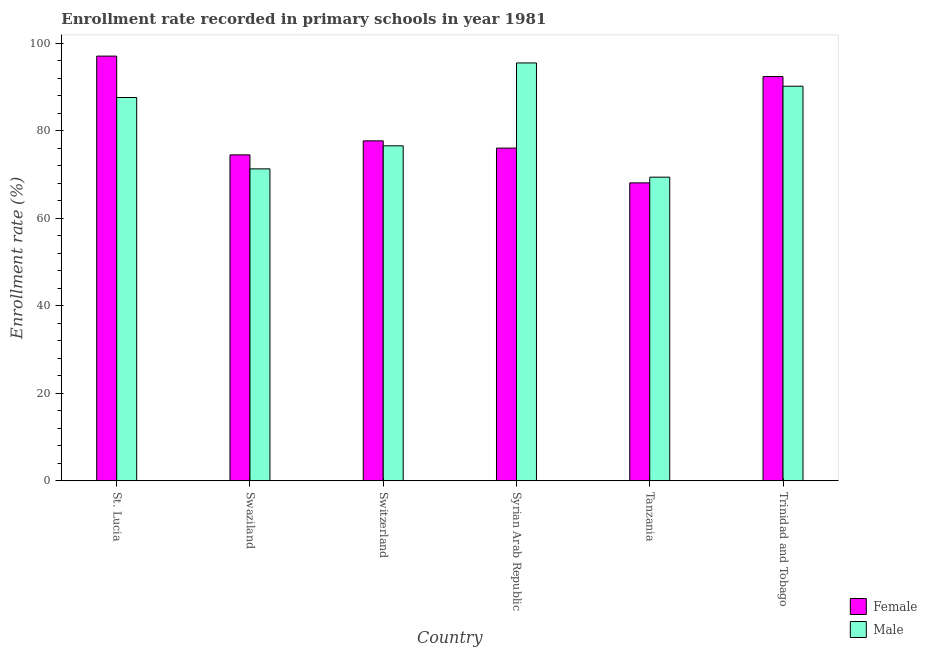How many bars are there on the 3rd tick from the left?
Your response must be concise. 2. What is the label of the 5th group of bars from the left?
Provide a short and direct response. Tanzania. In how many cases, is the number of bars for a given country not equal to the number of legend labels?
Offer a very short reply. 0. What is the enrollment rate of male students in Syrian Arab Republic?
Your answer should be very brief. 95.54. Across all countries, what is the maximum enrollment rate of male students?
Make the answer very short. 95.54. Across all countries, what is the minimum enrollment rate of female students?
Offer a terse response. 68.11. In which country was the enrollment rate of female students maximum?
Make the answer very short. St. Lucia. In which country was the enrollment rate of male students minimum?
Give a very brief answer. Tanzania. What is the total enrollment rate of male students in the graph?
Make the answer very short. 490.7. What is the difference between the enrollment rate of male students in St. Lucia and that in Trinidad and Tobago?
Provide a short and direct response. -2.58. What is the difference between the enrollment rate of female students in Syrian Arab Republic and the enrollment rate of male students in Switzerland?
Your answer should be compact. -0.52. What is the average enrollment rate of female students per country?
Keep it short and to the point. 80.99. What is the difference between the enrollment rate of male students and enrollment rate of female students in St. Lucia?
Your answer should be very brief. -9.46. What is the ratio of the enrollment rate of male students in Swaziland to that in Trinidad and Tobago?
Make the answer very short. 0.79. Is the difference between the enrollment rate of female students in St. Lucia and Syrian Arab Republic greater than the difference between the enrollment rate of male students in St. Lucia and Syrian Arab Republic?
Your response must be concise. Yes. What is the difference between the highest and the second highest enrollment rate of male students?
Give a very brief answer. 5.32. What is the difference between the highest and the lowest enrollment rate of male students?
Your answer should be compact. 26.12. In how many countries, is the enrollment rate of male students greater than the average enrollment rate of male students taken over all countries?
Ensure brevity in your answer.  3. Is the sum of the enrollment rate of female students in St. Lucia and Switzerland greater than the maximum enrollment rate of male students across all countries?
Provide a succinct answer. Yes. What does the 1st bar from the left in Syrian Arab Republic represents?
Your response must be concise. Female. What is the difference between two consecutive major ticks on the Y-axis?
Offer a terse response. 20. Does the graph contain any zero values?
Offer a very short reply. No. Does the graph contain grids?
Provide a short and direct response. No. How many legend labels are there?
Provide a short and direct response. 2. What is the title of the graph?
Provide a short and direct response. Enrollment rate recorded in primary schools in year 1981. Does "Forest" appear as one of the legend labels in the graph?
Ensure brevity in your answer.  No. What is the label or title of the X-axis?
Provide a short and direct response. Country. What is the label or title of the Y-axis?
Offer a very short reply. Enrollment rate (%). What is the Enrollment rate (%) of Female in St. Lucia?
Provide a short and direct response. 97.1. What is the Enrollment rate (%) in Male in St. Lucia?
Offer a terse response. 87.63. What is the Enrollment rate (%) of Female in Swaziland?
Your response must be concise. 74.51. What is the Enrollment rate (%) of Male in Swaziland?
Provide a short and direct response. 71.32. What is the Enrollment rate (%) of Female in Switzerland?
Provide a succinct answer. 77.72. What is the Enrollment rate (%) in Male in Switzerland?
Your answer should be very brief. 76.58. What is the Enrollment rate (%) in Female in Syrian Arab Republic?
Make the answer very short. 76.06. What is the Enrollment rate (%) in Male in Syrian Arab Republic?
Your answer should be very brief. 95.54. What is the Enrollment rate (%) in Female in Tanzania?
Offer a very short reply. 68.11. What is the Enrollment rate (%) of Male in Tanzania?
Provide a succinct answer. 69.42. What is the Enrollment rate (%) in Female in Trinidad and Tobago?
Ensure brevity in your answer.  92.42. What is the Enrollment rate (%) of Male in Trinidad and Tobago?
Offer a terse response. 90.21. Across all countries, what is the maximum Enrollment rate (%) in Female?
Offer a terse response. 97.1. Across all countries, what is the maximum Enrollment rate (%) of Male?
Offer a very short reply. 95.54. Across all countries, what is the minimum Enrollment rate (%) of Female?
Ensure brevity in your answer.  68.11. Across all countries, what is the minimum Enrollment rate (%) of Male?
Make the answer very short. 69.42. What is the total Enrollment rate (%) in Female in the graph?
Provide a succinct answer. 485.93. What is the total Enrollment rate (%) in Male in the graph?
Provide a succinct answer. 490.7. What is the difference between the Enrollment rate (%) in Female in St. Lucia and that in Swaziland?
Your answer should be very brief. 22.58. What is the difference between the Enrollment rate (%) of Male in St. Lucia and that in Swaziland?
Offer a terse response. 16.32. What is the difference between the Enrollment rate (%) of Female in St. Lucia and that in Switzerland?
Keep it short and to the point. 19.37. What is the difference between the Enrollment rate (%) in Male in St. Lucia and that in Switzerland?
Provide a succinct answer. 11.05. What is the difference between the Enrollment rate (%) of Female in St. Lucia and that in Syrian Arab Republic?
Ensure brevity in your answer.  21.03. What is the difference between the Enrollment rate (%) in Male in St. Lucia and that in Syrian Arab Republic?
Your answer should be compact. -7.9. What is the difference between the Enrollment rate (%) in Female in St. Lucia and that in Tanzania?
Your response must be concise. 28.98. What is the difference between the Enrollment rate (%) of Male in St. Lucia and that in Tanzania?
Make the answer very short. 18.22. What is the difference between the Enrollment rate (%) in Female in St. Lucia and that in Trinidad and Tobago?
Make the answer very short. 4.67. What is the difference between the Enrollment rate (%) in Male in St. Lucia and that in Trinidad and Tobago?
Ensure brevity in your answer.  -2.58. What is the difference between the Enrollment rate (%) of Female in Swaziland and that in Switzerland?
Give a very brief answer. -3.21. What is the difference between the Enrollment rate (%) in Male in Swaziland and that in Switzerland?
Your response must be concise. -5.27. What is the difference between the Enrollment rate (%) in Female in Swaziland and that in Syrian Arab Republic?
Give a very brief answer. -1.55. What is the difference between the Enrollment rate (%) of Male in Swaziland and that in Syrian Arab Republic?
Your response must be concise. -24.22. What is the difference between the Enrollment rate (%) of Female in Swaziland and that in Tanzania?
Provide a short and direct response. 6.4. What is the difference between the Enrollment rate (%) in Male in Swaziland and that in Tanzania?
Offer a very short reply. 1.9. What is the difference between the Enrollment rate (%) of Female in Swaziland and that in Trinidad and Tobago?
Make the answer very short. -17.91. What is the difference between the Enrollment rate (%) in Male in Swaziland and that in Trinidad and Tobago?
Provide a short and direct response. -18.9. What is the difference between the Enrollment rate (%) of Female in Switzerland and that in Syrian Arab Republic?
Your answer should be very brief. 1.66. What is the difference between the Enrollment rate (%) in Male in Switzerland and that in Syrian Arab Republic?
Your response must be concise. -18.95. What is the difference between the Enrollment rate (%) in Female in Switzerland and that in Tanzania?
Ensure brevity in your answer.  9.61. What is the difference between the Enrollment rate (%) of Male in Switzerland and that in Tanzania?
Your answer should be very brief. 7.17. What is the difference between the Enrollment rate (%) of Female in Switzerland and that in Trinidad and Tobago?
Make the answer very short. -14.7. What is the difference between the Enrollment rate (%) of Male in Switzerland and that in Trinidad and Tobago?
Keep it short and to the point. -13.63. What is the difference between the Enrollment rate (%) of Female in Syrian Arab Republic and that in Tanzania?
Make the answer very short. 7.95. What is the difference between the Enrollment rate (%) in Male in Syrian Arab Republic and that in Tanzania?
Your response must be concise. 26.12. What is the difference between the Enrollment rate (%) in Female in Syrian Arab Republic and that in Trinidad and Tobago?
Provide a short and direct response. -16.36. What is the difference between the Enrollment rate (%) of Male in Syrian Arab Republic and that in Trinidad and Tobago?
Keep it short and to the point. 5.32. What is the difference between the Enrollment rate (%) in Female in Tanzania and that in Trinidad and Tobago?
Provide a succinct answer. -24.31. What is the difference between the Enrollment rate (%) in Male in Tanzania and that in Trinidad and Tobago?
Ensure brevity in your answer.  -20.79. What is the difference between the Enrollment rate (%) of Female in St. Lucia and the Enrollment rate (%) of Male in Swaziland?
Your answer should be compact. 25.78. What is the difference between the Enrollment rate (%) in Female in St. Lucia and the Enrollment rate (%) in Male in Switzerland?
Your answer should be compact. 20.51. What is the difference between the Enrollment rate (%) of Female in St. Lucia and the Enrollment rate (%) of Male in Syrian Arab Republic?
Ensure brevity in your answer.  1.56. What is the difference between the Enrollment rate (%) of Female in St. Lucia and the Enrollment rate (%) of Male in Tanzania?
Make the answer very short. 27.68. What is the difference between the Enrollment rate (%) of Female in St. Lucia and the Enrollment rate (%) of Male in Trinidad and Tobago?
Your response must be concise. 6.88. What is the difference between the Enrollment rate (%) in Female in Swaziland and the Enrollment rate (%) in Male in Switzerland?
Ensure brevity in your answer.  -2.07. What is the difference between the Enrollment rate (%) in Female in Swaziland and the Enrollment rate (%) in Male in Syrian Arab Republic?
Make the answer very short. -21.02. What is the difference between the Enrollment rate (%) in Female in Swaziland and the Enrollment rate (%) in Male in Tanzania?
Make the answer very short. 5.1. What is the difference between the Enrollment rate (%) of Female in Swaziland and the Enrollment rate (%) of Male in Trinidad and Tobago?
Your response must be concise. -15.7. What is the difference between the Enrollment rate (%) of Female in Switzerland and the Enrollment rate (%) of Male in Syrian Arab Republic?
Keep it short and to the point. -17.81. What is the difference between the Enrollment rate (%) of Female in Switzerland and the Enrollment rate (%) of Male in Tanzania?
Give a very brief answer. 8.3. What is the difference between the Enrollment rate (%) of Female in Switzerland and the Enrollment rate (%) of Male in Trinidad and Tobago?
Offer a terse response. -12.49. What is the difference between the Enrollment rate (%) of Female in Syrian Arab Republic and the Enrollment rate (%) of Male in Tanzania?
Provide a succinct answer. 6.64. What is the difference between the Enrollment rate (%) in Female in Syrian Arab Republic and the Enrollment rate (%) in Male in Trinidad and Tobago?
Make the answer very short. -14.15. What is the difference between the Enrollment rate (%) in Female in Tanzania and the Enrollment rate (%) in Male in Trinidad and Tobago?
Provide a succinct answer. -22.1. What is the average Enrollment rate (%) in Female per country?
Provide a succinct answer. 80.99. What is the average Enrollment rate (%) of Male per country?
Ensure brevity in your answer.  81.78. What is the difference between the Enrollment rate (%) of Female and Enrollment rate (%) of Male in St. Lucia?
Offer a very short reply. 9.46. What is the difference between the Enrollment rate (%) of Female and Enrollment rate (%) of Male in Swaziland?
Offer a terse response. 3.2. What is the difference between the Enrollment rate (%) of Female and Enrollment rate (%) of Male in Switzerland?
Provide a short and direct response. 1.14. What is the difference between the Enrollment rate (%) in Female and Enrollment rate (%) in Male in Syrian Arab Republic?
Your response must be concise. -19.47. What is the difference between the Enrollment rate (%) of Female and Enrollment rate (%) of Male in Tanzania?
Ensure brevity in your answer.  -1.31. What is the difference between the Enrollment rate (%) in Female and Enrollment rate (%) in Male in Trinidad and Tobago?
Offer a terse response. 2.21. What is the ratio of the Enrollment rate (%) in Female in St. Lucia to that in Swaziland?
Give a very brief answer. 1.3. What is the ratio of the Enrollment rate (%) in Male in St. Lucia to that in Swaziland?
Provide a succinct answer. 1.23. What is the ratio of the Enrollment rate (%) of Female in St. Lucia to that in Switzerland?
Give a very brief answer. 1.25. What is the ratio of the Enrollment rate (%) of Male in St. Lucia to that in Switzerland?
Ensure brevity in your answer.  1.14. What is the ratio of the Enrollment rate (%) of Female in St. Lucia to that in Syrian Arab Republic?
Provide a short and direct response. 1.28. What is the ratio of the Enrollment rate (%) of Male in St. Lucia to that in Syrian Arab Republic?
Your answer should be very brief. 0.92. What is the ratio of the Enrollment rate (%) of Female in St. Lucia to that in Tanzania?
Your response must be concise. 1.43. What is the ratio of the Enrollment rate (%) of Male in St. Lucia to that in Tanzania?
Make the answer very short. 1.26. What is the ratio of the Enrollment rate (%) in Female in St. Lucia to that in Trinidad and Tobago?
Your answer should be very brief. 1.05. What is the ratio of the Enrollment rate (%) in Male in St. Lucia to that in Trinidad and Tobago?
Make the answer very short. 0.97. What is the ratio of the Enrollment rate (%) in Female in Swaziland to that in Switzerland?
Provide a short and direct response. 0.96. What is the ratio of the Enrollment rate (%) in Male in Swaziland to that in Switzerland?
Ensure brevity in your answer.  0.93. What is the ratio of the Enrollment rate (%) in Female in Swaziland to that in Syrian Arab Republic?
Make the answer very short. 0.98. What is the ratio of the Enrollment rate (%) in Male in Swaziland to that in Syrian Arab Republic?
Your answer should be very brief. 0.75. What is the ratio of the Enrollment rate (%) of Female in Swaziland to that in Tanzania?
Keep it short and to the point. 1.09. What is the ratio of the Enrollment rate (%) in Male in Swaziland to that in Tanzania?
Keep it short and to the point. 1.03. What is the ratio of the Enrollment rate (%) in Female in Swaziland to that in Trinidad and Tobago?
Your answer should be compact. 0.81. What is the ratio of the Enrollment rate (%) of Male in Swaziland to that in Trinidad and Tobago?
Your answer should be compact. 0.79. What is the ratio of the Enrollment rate (%) in Female in Switzerland to that in Syrian Arab Republic?
Offer a terse response. 1.02. What is the ratio of the Enrollment rate (%) of Male in Switzerland to that in Syrian Arab Republic?
Offer a terse response. 0.8. What is the ratio of the Enrollment rate (%) in Female in Switzerland to that in Tanzania?
Give a very brief answer. 1.14. What is the ratio of the Enrollment rate (%) of Male in Switzerland to that in Tanzania?
Your answer should be very brief. 1.1. What is the ratio of the Enrollment rate (%) of Female in Switzerland to that in Trinidad and Tobago?
Ensure brevity in your answer.  0.84. What is the ratio of the Enrollment rate (%) in Male in Switzerland to that in Trinidad and Tobago?
Keep it short and to the point. 0.85. What is the ratio of the Enrollment rate (%) in Female in Syrian Arab Republic to that in Tanzania?
Keep it short and to the point. 1.12. What is the ratio of the Enrollment rate (%) in Male in Syrian Arab Republic to that in Tanzania?
Provide a short and direct response. 1.38. What is the ratio of the Enrollment rate (%) in Female in Syrian Arab Republic to that in Trinidad and Tobago?
Your response must be concise. 0.82. What is the ratio of the Enrollment rate (%) in Male in Syrian Arab Republic to that in Trinidad and Tobago?
Offer a terse response. 1.06. What is the ratio of the Enrollment rate (%) in Female in Tanzania to that in Trinidad and Tobago?
Provide a succinct answer. 0.74. What is the ratio of the Enrollment rate (%) in Male in Tanzania to that in Trinidad and Tobago?
Your response must be concise. 0.77. What is the difference between the highest and the second highest Enrollment rate (%) in Female?
Offer a terse response. 4.67. What is the difference between the highest and the second highest Enrollment rate (%) in Male?
Provide a short and direct response. 5.32. What is the difference between the highest and the lowest Enrollment rate (%) in Female?
Your answer should be compact. 28.98. What is the difference between the highest and the lowest Enrollment rate (%) of Male?
Make the answer very short. 26.12. 